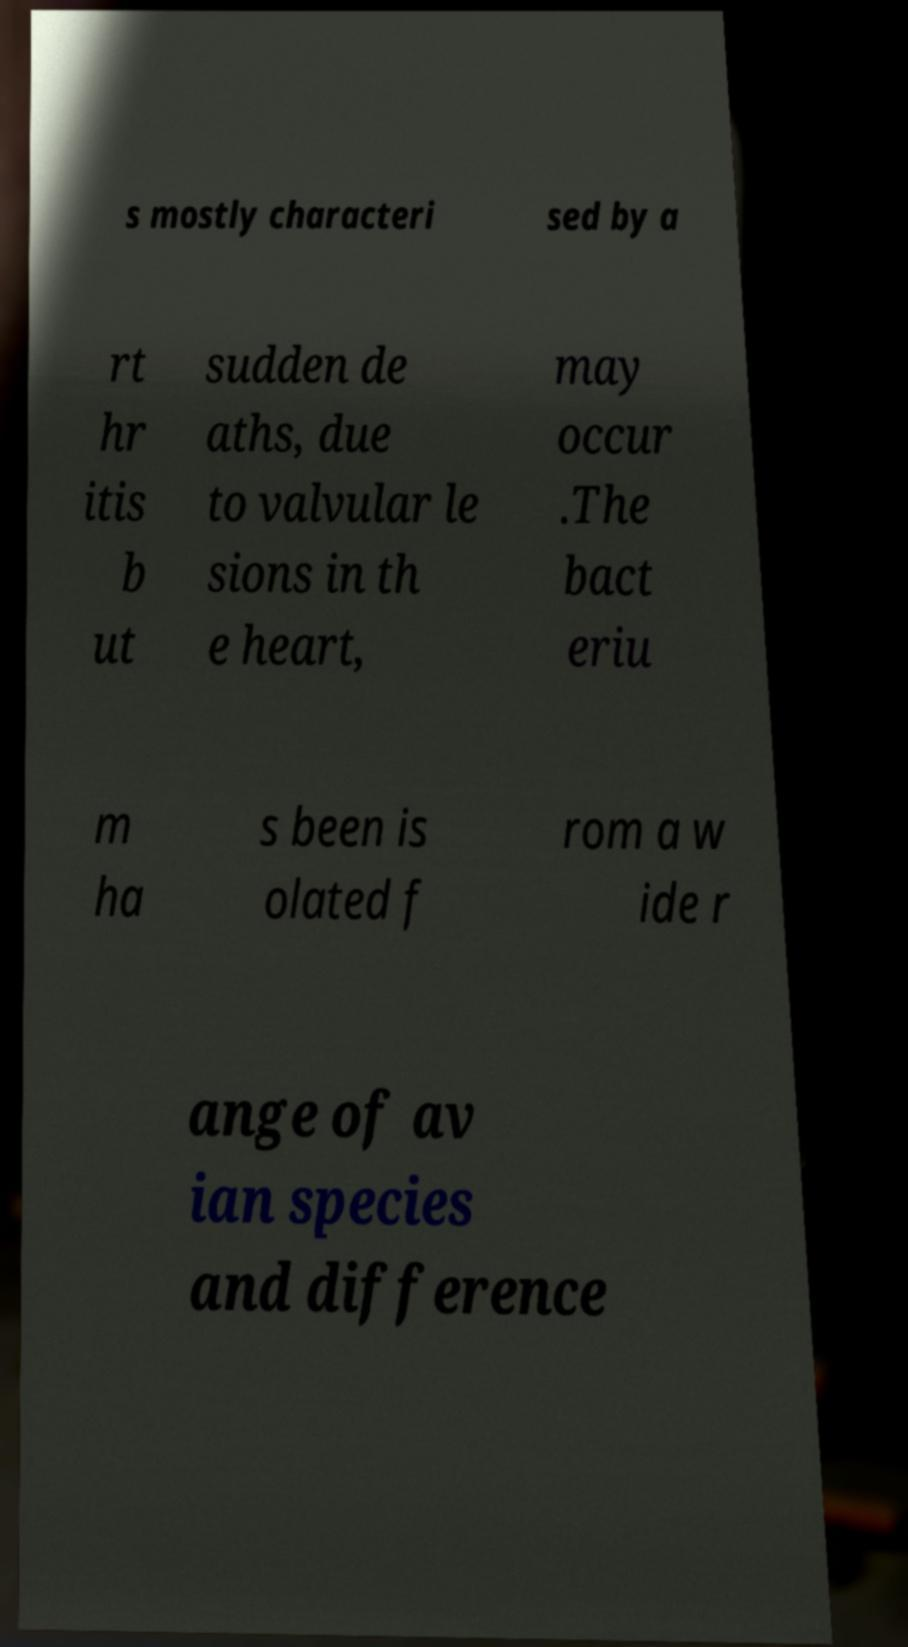Can you read and provide the text displayed in the image?This photo seems to have some interesting text. Can you extract and type it out for me? s mostly characteri sed by a rt hr itis b ut sudden de aths, due to valvular le sions in th e heart, may occur .The bact eriu m ha s been is olated f rom a w ide r ange of av ian species and difference 